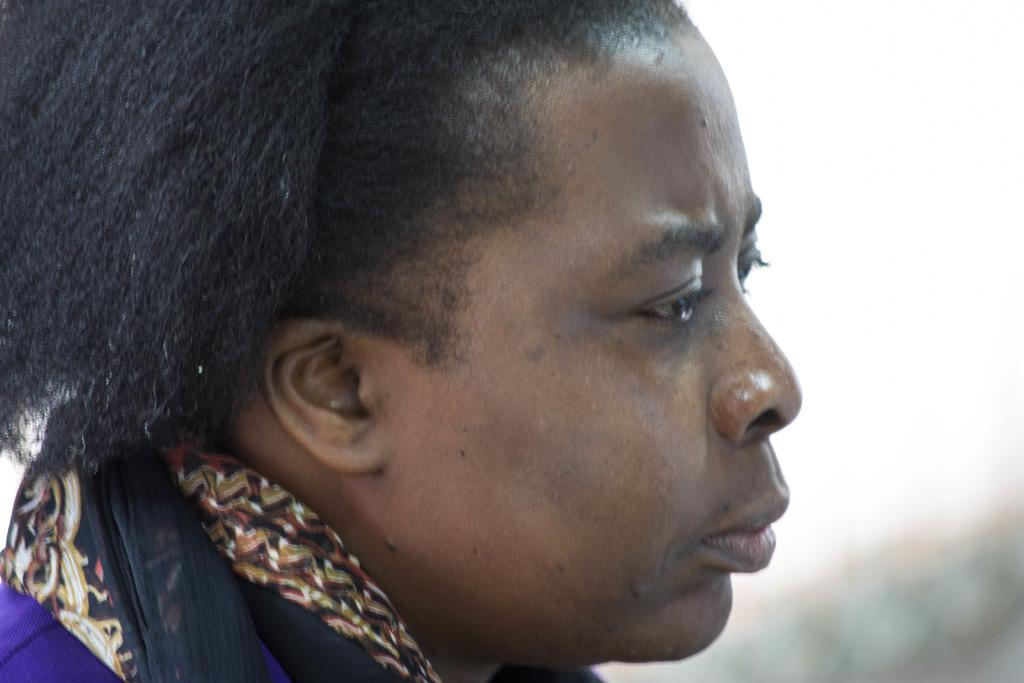What is the main subject of the image? There is a person's face in the image. Can you describe the background of the image? The background of the image is blurry. How many bikes are parked near the gate in the image? There is no gate or bikes present in the image; it only features a person's face with a blurry background. 